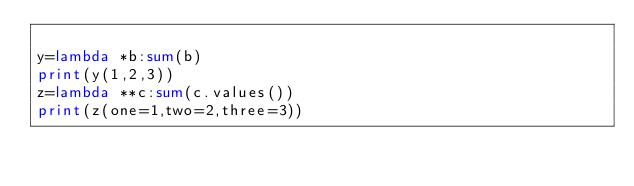<code> <loc_0><loc_0><loc_500><loc_500><_Python_>
y=lambda *b:sum(b)
print(y(1,2,3))
z=lambda **c:sum(c.values())
print(z(one=1,two=2,three=3))</code> 